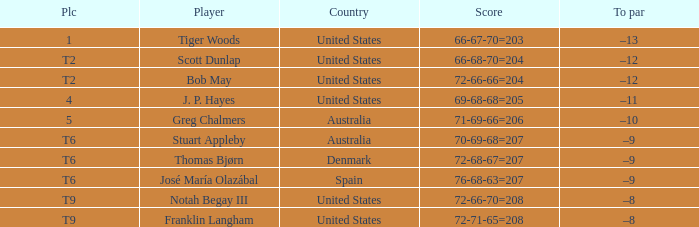What country is player thomas bjørn from? Denmark. 